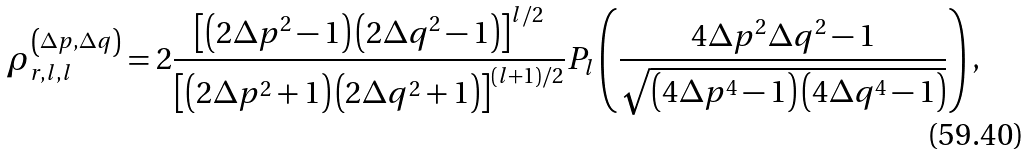Convert formula to latex. <formula><loc_0><loc_0><loc_500><loc_500>\rho _ { r , l , l } ^ { \left ( \Delta p , \Delta q \right ) } = 2 \frac { \left [ \left ( 2 \Delta p ^ { 2 } - 1 \right ) \left ( 2 \Delta q ^ { 2 } - 1 \right ) \right ] ^ { l / 2 } } { \left [ \left ( 2 \Delta p ^ { 2 } + 1 \right ) \left ( 2 \Delta q ^ { 2 } + 1 \right ) \right ] ^ { \left ( l + 1 \right ) / 2 } } P _ { l } \left ( \frac { 4 \Delta p ^ { 2 } \Delta q ^ { 2 } - 1 } { \sqrt { \left ( 4 \Delta p ^ { 4 } - 1 \right ) \left ( 4 \Delta q ^ { 4 } - 1 \right ) } } \right ) ,</formula> 